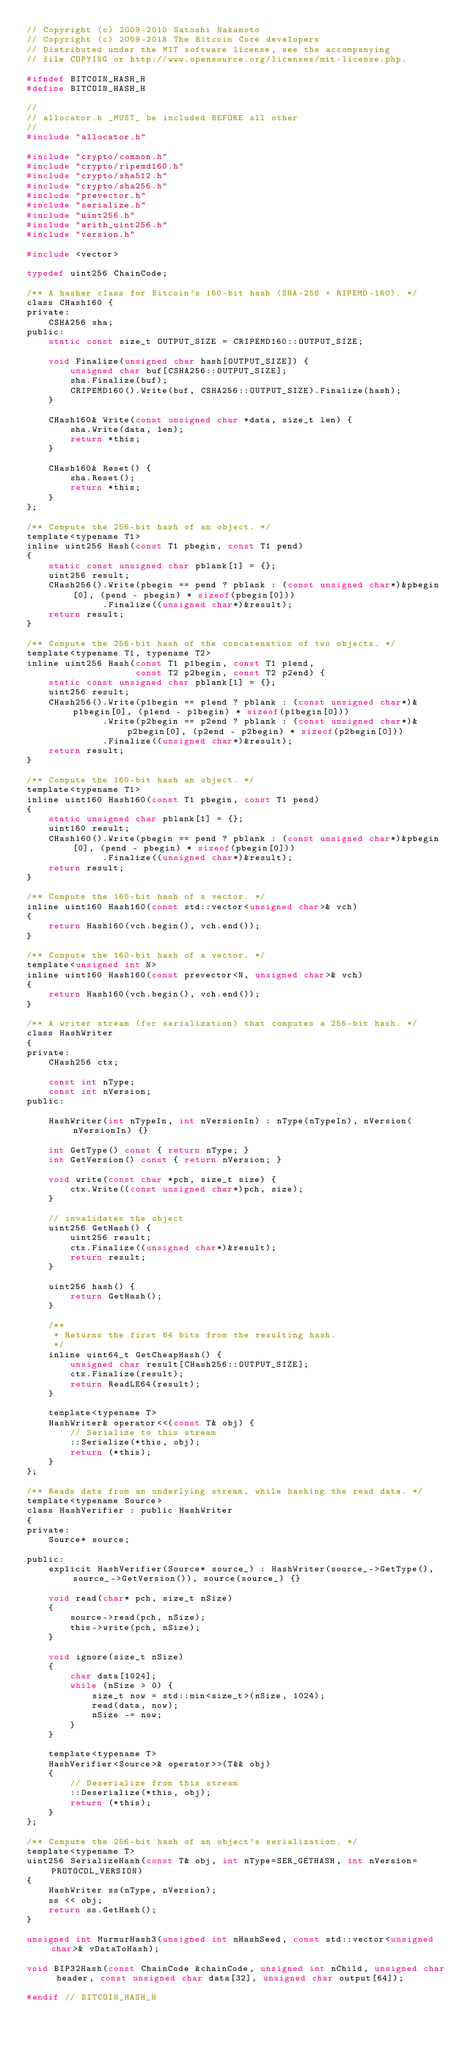Convert code to text. <code><loc_0><loc_0><loc_500><loc_500><_C_>// Copyright (c) 2009-2010 Satoshi Nakamoto
// Copyright (c) 2009-2018 The Bitcoin Core developers
// Distributed under the MIT software license, see the accompanying
// file COPYING or http://www.opensource.org/licenses/mit-license.php.

#ifndef BITCOIN_HASH_H
#define BITCOIN_HASH_H

//
// allocator.h _MUST_ be included BEFORE all other
//
#include "allocator.h"

#include "crypto/common.h"
#include "crypto/ripemd160.h"
#include "crypto/sha512.h"
#include "crypto/sha256.h"
#include "prevector.h"
#include "serialize.h"
#include "uint256.h"
#include "arith_uint256.h"
#include "version.h"

#include <vector>

typedef uint256 ChainCode;

/** A hasher class for Bitcoin's 160-bit hash (SHA-256 + RIPEMD-160). */
class CHash160 {
private:
    CSHA256 sha;
public:
    static const size_t OUTPUT_SIZE = CRIPEMD160::OUTPUT_SIZE;

    void Finalize(unsigned char hash[OUTPUT_SIZE]) {
        unsigned char buf[CSHA256::OUTPUT_SIZE];
        sha.Finalize(buf);
        CRIPEMD160().Write(buf, CSHA256::OUTPUT_SIZE).Finalize(hash);
    }

    CHash160& Write(const unsigned char *data, size_t len) {
        sha.Write(data, len);
        return *this;
    }

    CHash160& Reset() {
        sha.Reset();
        return *this;
    }
};

/** Compute the 256-bit hash of an object. */
template<typename T1>
inline uint256 Hash(const T1 pbegin, const T1 pend)
{
    static const unsigned char pblank[1] = {};
    uint256 result;
    CHash256().Write(pbegin == pend ? pblank : (const unsigned char*)&pbegin[0], (pend - pbegin) * sizeof(pbegin[0]))
              .Finalize((unsigned char*)&result);
    return result;
}

/** Compute the 256-bit hash of the concatenation of two objects. */
template<typename T1, typename T2>
inline uint256 Hash(const T1 p1begin, const T1 p1end,
                    const T2 p2begin, const T2 p2end) {
    static const unsigned char pblank[1] = {};
    uint256 result;
    CHash256().Write(p1begin == p1end ? pblank : (const unsigned char*)&p1begin[0], (p1end - p1begin) * sizeof(p1begin[0]))
              .Write(p2begin == p2end ? pblank : (const unsigned char*)&p2begin[0], (p2end - p2begin) * sizeof(p2begin[0]))
              .Finalize((unsigned char*)&result);
    return result;
}

/** Compute the 160-bit hash an object. */
template<typename T1>
inline uint160 Hash160(const T1 pbegin, const T1 pend)
{
    static unsigned char pblank[1] = {};
    uint160 result;
    CHash160().Write(pbegin == pend ? pblank : (const unsigned char*)&pbegin[0], (pend - pbegin) * sizeof(pbegin[0]))
              .Finalize((unsigned char*)&result);
    return result;
}

/** Compute the 160-bit hash of a vector. */
inline uint160 Hash160(const std::vector<unsigned char>& vch)
{
    return Hash160(vch.begin(), vch.end());
}

/** Compute the 160-bit hash of a vector. */
template<unsigned int N>
inline uint160 Hash160(const prevector<N, unsigned char>& vch)
{
    return Hash160(vch.begin(), vch.end());
}

/** A writer stream (for serialization) that computes a 256-bit hash. */
class HashWriter
{
private:
    CHash256 ctx;

    const int nType;
    const int nVersion;
public:

    HashWriter(int nTypeIn, int nVersionIn) : nType(nTypeIn), nVersion(nVersionIn) {}

    int GetType() const { return nType; }
    int GetVersion() const { return nVersion; }

    void write(const char *pch, size_t size) {
        ctx.Write((const unsigned char*)pch, size);
    }

    // invalidates the object
    uint256 GetHash() {
        uint256 result;
        ctx.Finalize((unsigned char*)&result);
        return result;
    }

    uint256 hash() {
        return GetHash();
    }

    /**
     * Returns the first 64 bits from the resulting hash.
     */
    inline uint64_t GetCheapHash() {
        unsigned char result[CHash256::OUTPUT_SIZE];
        ctx.Finalize(result);
        return ReadLE64(result);
    }

    template<typename T>
    HashWriter& operator<<(const T& obj) {
        // Serialize to this stream
        ::Serialize(*this, obj);
        return (*this);
    }
};

/** Reads data from an underlying stream, while hashing the read data. */
template<typename Source>
class HashVerifier : public HashWriter
{
private:
    Source* source;

public:
    explicit HashVerifier(Source* source_) : HashWriter(source_->GetType(), source_->GetVersion()), source(source_) {}

    void read(char* pch, size_t nSize)
    {
        source->read(pch, nSize);
        this->write(pch, nSize);
    }

    void ignore(size_t nSize)
    {
        char data[1024];
        while (nSize > 0) {
            size_t now = std::min<size_t>(nSize, 1024);
            read(data, now);
            nSize -= now;
        }
    }

    template<typename T>
    HashVerifier<Source>& operator>>(T&& obj)
    {
        // Deserialize from this stream
        ::Deserialize(*this, obj);
        return (*this);
    }
};

/** Compute the 256-bit hash of an object's serialization. */
template<typename T>
uint256 SerializeHash(const T& obj, int nType=SER_GETHASH, int nVersion=PROTOCOL_VERSION)
{
    HashWriter ss(nType, nVersion);
    ss << obj;
    return ss.GetHash();
}

unsigned int MurmurHash3(unsigned int nHashSeed, const std::vector<unsigned char>& vDataToHash);

void BIP32Hash(const ChainCode &chainCode, unsigned int nChild, unsigned char header, const unsigned char data[32], unsigned char output[64]);

#endif // BITCOIN_HASH_H
</code> 